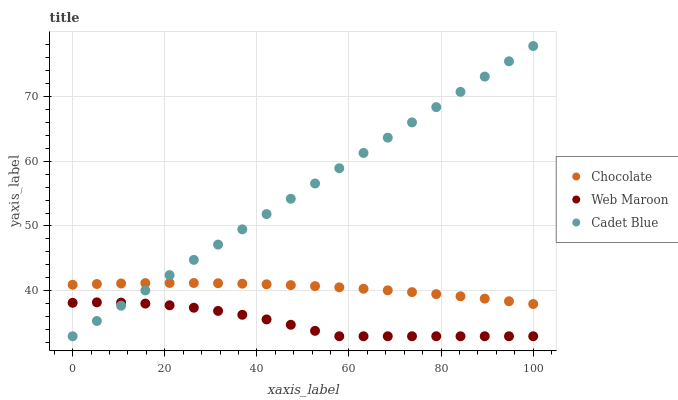Does Web Maroon have the minimum area under the curve?
Answer yes or no. Yes. Does Cadet Blue have the maximum area under the curve?
Answer yes or no. Yes. Does Chocolate have the minimum area under the curve?
Answer yes or no. No. Does Chocolate have the maximum area under the curve?
Answer yes or no. No. Is Cadet Blue the smoothest?
Answer yes or no. Yes. Is Web Maroon the roughest?
Answer yes or no. Yes. Is Chocolate the smoothest?
Answer yes or no. No. Is Chocolate the roughest?
Answer yes or no. No. Does Cadet Blue have the lowest value?
Answer yes or no. Yes. Does Chocolate have the lowest value?
Answer yes or no. No. Does Cadet Blue have the highest value?
Answer yes or no. Yes. Does Chocolate have the highest value?
Answer yes or no. No. Is Web Maroon less than Chocolate?
Answer yes or no. Yes. Is Chocolate greater than Web Maroon?
Answer yes or no. Yes. Does Cadet Blue intersect Web Maroon?
Answer yes or no. Yes. Is Cadet Blue less than Web Maroon?
Answer yes or no. No. Is Cadet Blue greater than Web Maroon?
Answer yes or no. No. Does Web Maroon intersect Chocolate?
Answer yes or no. No. 